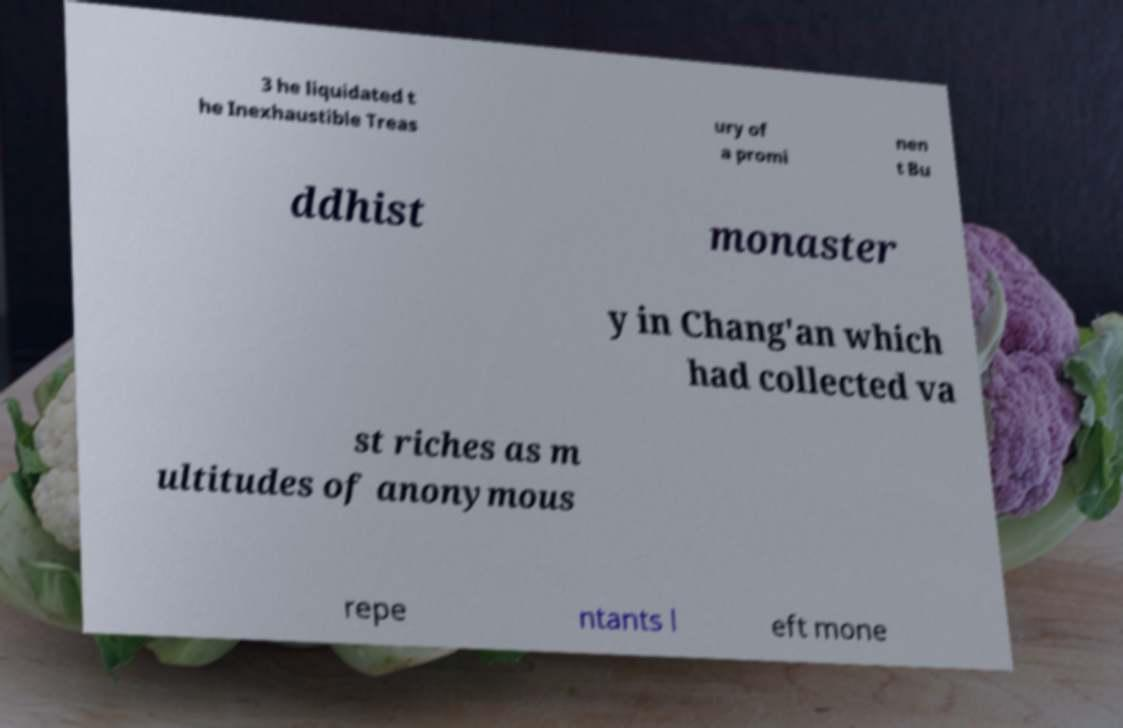Can you read and provide the text displayed in the image?This photo seems to have some interesting text. Can you extract and type it out for me? 3 he liquidated t he Inexhaustible Treas ury of a promi nen t Bu ddhist monaster y in Chang'an which had collected va st riches as m ultitudes of anonymous repe ntants l eft mone 